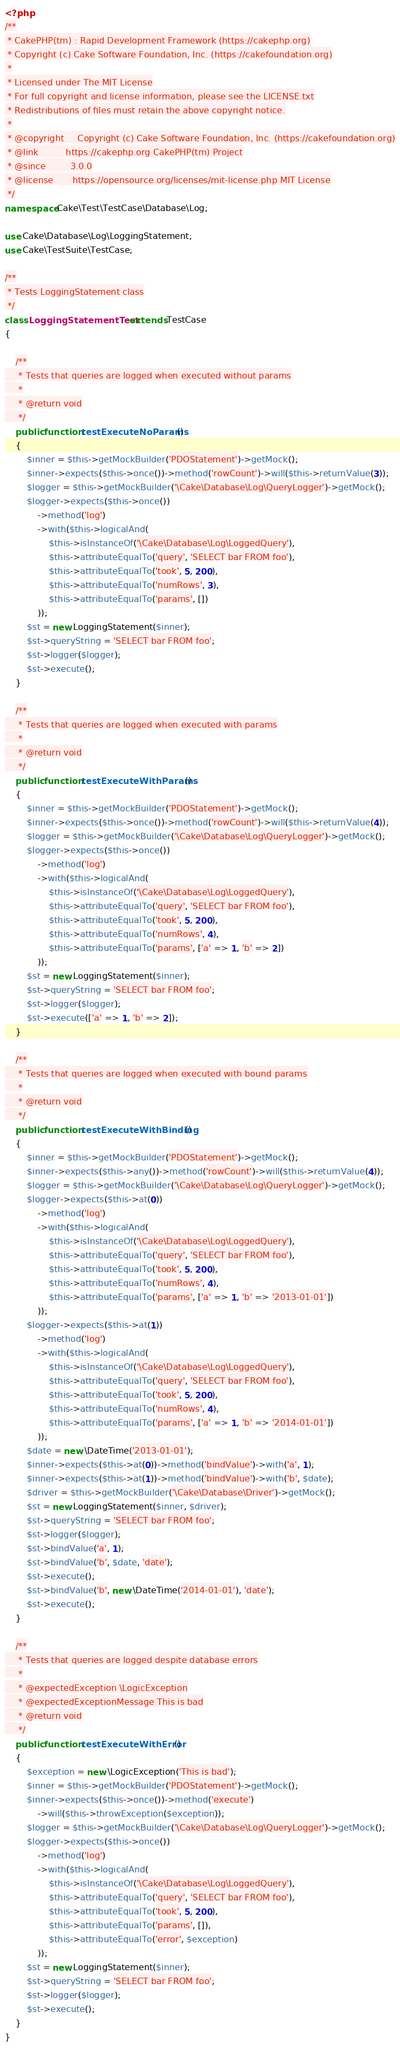Convert code to text. <code><loc_0><loc_0><loc_500><loc_500><_PHP_><?php
/**
 * CakePHP(tm) : Rapid Development Framework (https://cakephp.org)
 * Copyright (c) Cake Software Foundation, Inc. (https://cakefoundation.org)
 *
 * Licensed under The MIT License
 * For full copyright and license information, please see the LICENSE.txt
 * Redistributions of files must retain the above copyright notice.
 *
 * @copyright     Copyright (c) Cake Software Foundation, Inc. (https://cakefoundation.org)
 * @link          https://cakephp.org CakePHP(tm) Project
 * @since         3.0.0
 * @license       https://opensource.org/licenses/mit-license.php MIT License
 */
namespace Cake\Test\TestCase\Database\Log;

use Cake\Database\Log\LoggingStatement;
use Cake\TestSuite\TestCase;

/**
 * Tests LoggingStatement class
 */
class LoggingStatementTest extends TestCase
{

    /**
     * Tests that queries are logged when executed without params
     *
     * @return void
     */
    public function testExecuteNoParams()
    {
        $inner = $this->getMockBuilder('PDOStatement')->getMock();
        $inner->expects($this->once())->method('rowCount')->will($this->returnValue(3));
        $logger = $this->getMockBuilder('\Cake\Database\Log\QueryLogger')->getMock();
        $logger->expects($this->once())
            ->method('log')
            ->with($this->logicalAnd(
                $this->isInstanceOf('\Cake\Database\Log\LoggedQuery'),
                $this->attributeEqualTo('query', 'SELECT bar FROM foo'),
                $this->attributeEqualTo('took', 5, 200),
                $this->attributeEqualTo('numRows', 3),
                $this->attributeEqualTo('params', [])
            ));
        $st = new LoggingStatement($inner);
        $st->queryString = 'SELECT bar FROM foo';
        $st->logger($logger);
        $st->execute();
    }

    /**
     * Tests that queries are logged when executed with params
     *
     * @return void
     */
    public function testExecuteWithParams()
    {
        $inner = $this->getMockBuilder('PDOStatement')->getMock();
        $inner->expects($this->once())->method('rowCount')->will($this->returnValue(4));
        $logger = $this->getMockBuilder('\Cake\Database\Log\QueryLogger')->getMock();
        $logger->expects($this->once())
            ->method('log')
            ->with($this->logicalAnd(
                $this->isInstanceOf('\Cake\Database\Log\LoggedQuery'),
                $this->attributeEqualTo('query', 'SELECT bar FROM foo'),
                $this->attributeEqualTo('took', 5, 200),
                $this->attributeEqualTo('numRows', 4),
                $this->attributeEqualTo('params', ['a' => 1, 'b' => 2])
            ));
        $st = new LoggingStatement($inner);
        $st->queryString = 'SELECT bar FROM foo';
        $st->logger($logger);
        $st->execute(['a' => 1, 'b' => 2]);
    }

    /**
     * Tests that queries are logged when executed with bound params
     *
     * @return void
     */
    public function testExecuteWithBinding()
    {
        $inner = $this->getMockBuilder('PDOStatement')->getMock();
        $inner->expects($this->any())->method('rowCount')->will($this->returnValue(4));
        $logger = $this->getMockBuilder('\Cake\Database\Log\QueryLogger')->getMock();
        $logger->expects($this->at(0))
            ->method('log')
            ->with($this->logicalAnd(
                $this->isInstanceOf('\Cake\Database\Log\LoggedQuery'),
                $this->attributeEqualTo('query', 'SELECT bar FROM foo'),
                $this->attributeEqualTo('took', 5, 200),
                $this->attributeEqualTo('numRows', 4),
                $this->attributeEqualTo('params', ['a' => 1, 'b' => '2013-01-01'])
            ));
        $logger->expects($this->at(1))
            ->method('log')
            ->with($this->logicalAnd(
                $this->isInstanceOf('\Cake\Database\Log\LoggedQuery'),
                $this->attributeEqualTo('query', 'SELECT bar FROM foo'),
                $this->attributeEqualTo('took', 5, 200),
                $this->attributeEqualTo('numRows', 4),
                $this->attributeEqualTo('params', ['a' => 1, 'b' => '2014-01-01'])
            ));
        $date = new \DateTime('2013-01-01');
        $inner->expects($this->at(0))->method('bindValue')->with('a', 1);
        $inner->expects($this->at(1))->method('bindValue')->with('b', $date);
        $driver = $this->getMockBuilder('\Cake\Database\Driver')->getMock();
        $st = new LoggingStatement($inner, $driver);
        $st->queryString = 'SELECT bar FROM foo';
        $st->logger($logger);
        $st->bindValue('a', 1);
        $st->bindValue('b', $date, 'date');
        $st->execute();
        $st->bindValue('b', new \DateTime('2014-01-01'), 'date');
        $st->execute();
    }

    /**
     * Tests that queries are logged despite database errors
     *
     * @expectedException \LogicException
     * @expectedExceptionMessage This is bad
     * @return void
     */
    public function testExecuteWithError()
    {
        $exception = new \LogicException('This is bad');
        $inner = $this->getMockBuilder('PDOStatement')->getMock();
        $inner->expects($this->once())->method('execute')
            ->will($this->throwException($exception));
        $logger = $this->getMockBuilder('\Cake\Database\Log\QueryLogger')->getMock();
        $logger->expects($this->once())
            ->method('log')
            ->with($this->logicalAnd(
                $this->isInstanceOf('\Cake\Database\Log\LoggedQuery'),
                $this->attributeEqualTo('query', 'SELECT bar FROM foo'),
                $this->attributeEqualTo('took', 5, 200),
                $this->attributeEqualTo('params', []),
                $this->attributeEqualTo('error', $exception)
            ));
        $st = new LoggingStatement($inner);
        $st->queryString = 'SELECT bar FROM foo';
        $st->logger($logger);
        $st->execute();
    }
}
</code> 